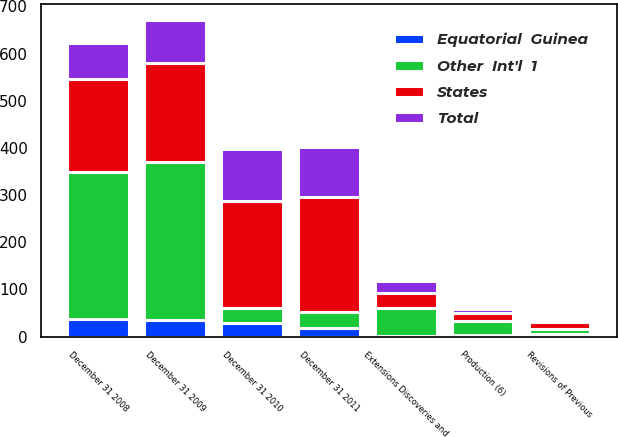<chart> <loc_0><loc_0><loc_500><loc_500><stacked_bar_chart><ecel><fcel>December 31 2008<fcel>Extensions Discoveries and<fcel>Production (6)<fcel>December 31 2009<fcel>Revisions of Previous<fcel>December 31 2010<fcel>December 31 2011<nl><fcel>States<fcel>198<fcel>32<fcel>17<fcel>209<fcel>15<fcel>225<fcel>244<nl><fcel>Total<fcel>75<fcel>26<fcel>8<fcel>92<fcel>1<fcel>112<fcel>106<nl><fcel>Equatorial  Guinea<fcel>38<fcel>1<fcel>4<fcel>35<fcel>5<fcel>28<fcel>19<nl><fcel>Other  Int'l  1<fcel>311<fcel>59<fcel>29<fcel>336<fcel>11<fcel>33.5<fcel>33.5<nl></chart> 